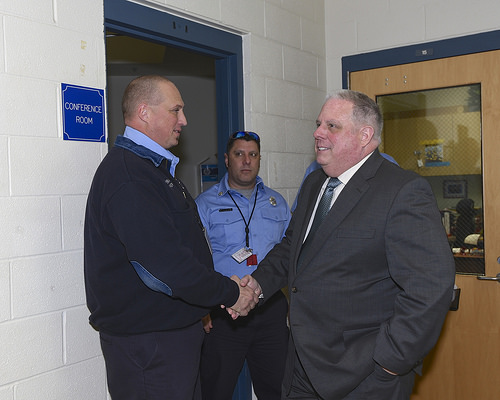<image>
Can you confirm if the man is on the man? No. The man is not positioned on the man. They may be near each other, but the man is not supported by or resting on top of the man. Is there a man in front of the man? No. The man is not in front of the man. The spatial positioning shows a different relationship between these objects. 